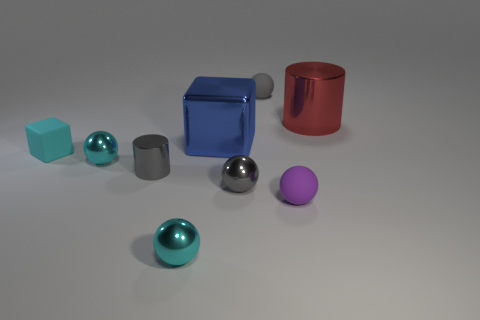How many rubber balls have the same color as the big cylinder?
Your answer should be compact. 0. The red cylinder that is the same material as the large block is what size?
Keep it short and to the point. Large. What shape is the gray metal thing on the right side of the big blue metallic block?
Ensure brevity in your answer.  Sphere. What size is the gray metal object that is the same shape as the purple object?
Make the answer very short. Small. There is a tiny metallic thing right of the cube behind the cyan matte thing; how many large things are right of it?
Your answer should be very brief. 1. Is the number of objects that are behind the red metallic object the same as the number of gray spheres?
Your answer should be compact. No. What number of cubes are either big yellow matte things or small cyan matte objects?
Give a very brief answer. 1. Does the tiny cylinder have the same color as the tiny matte block?
Your response must be concise. No. Are there the same number of red metal objects that are behind the purple rubber thing and tiny purple balls behind the small gray shiny sphere?
Make the answer very short. No. What color is the big block?
Make the answer very short. Blue. 